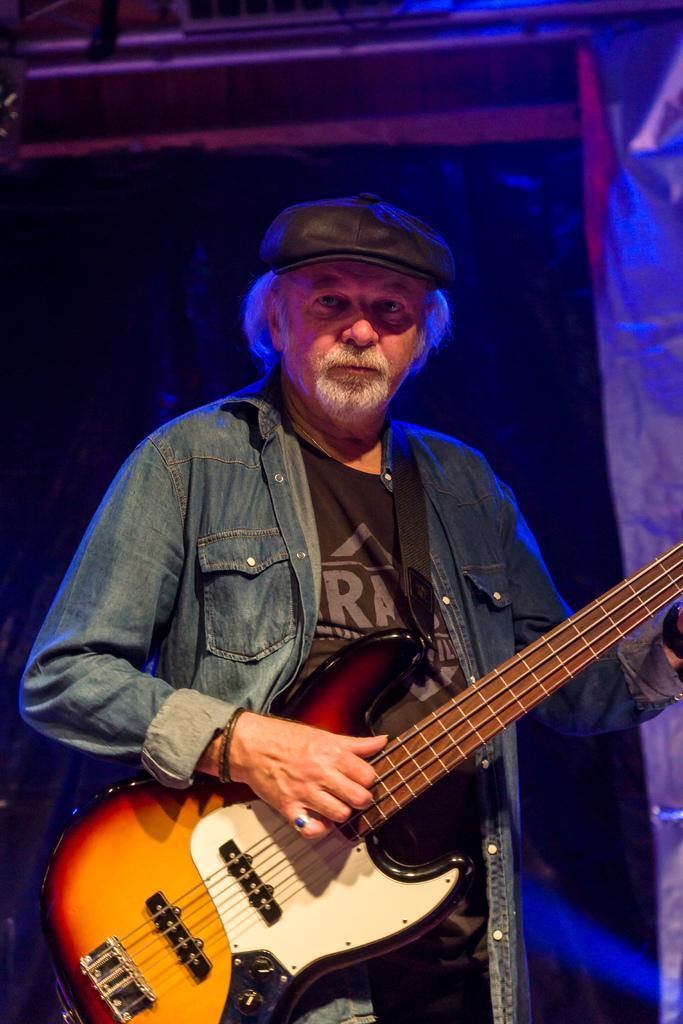Describe this image in one or two sentences. This person is standing and playing a guitar. This person wore jacket and cap. 